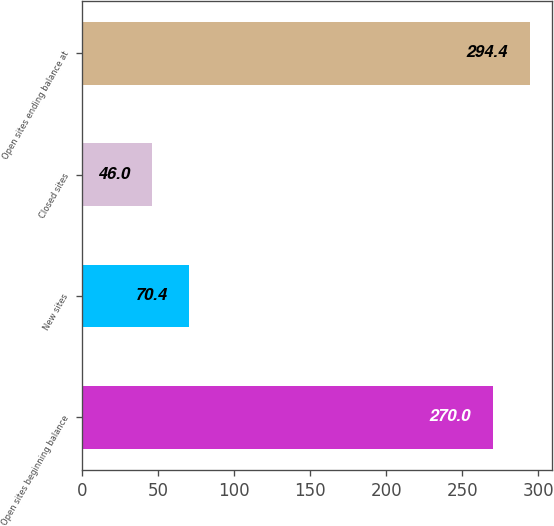<chart> <loc_0><loc_0><loc_500><loc_500><bar_chart><fcel>Open sites beginning balance<fcel>New sites<fcel>Closed sites<fcel>Open sites ending balance at<nl><fcel>270<fcel>70.4<fcel>46<fcel>294.4<nl></chart> 